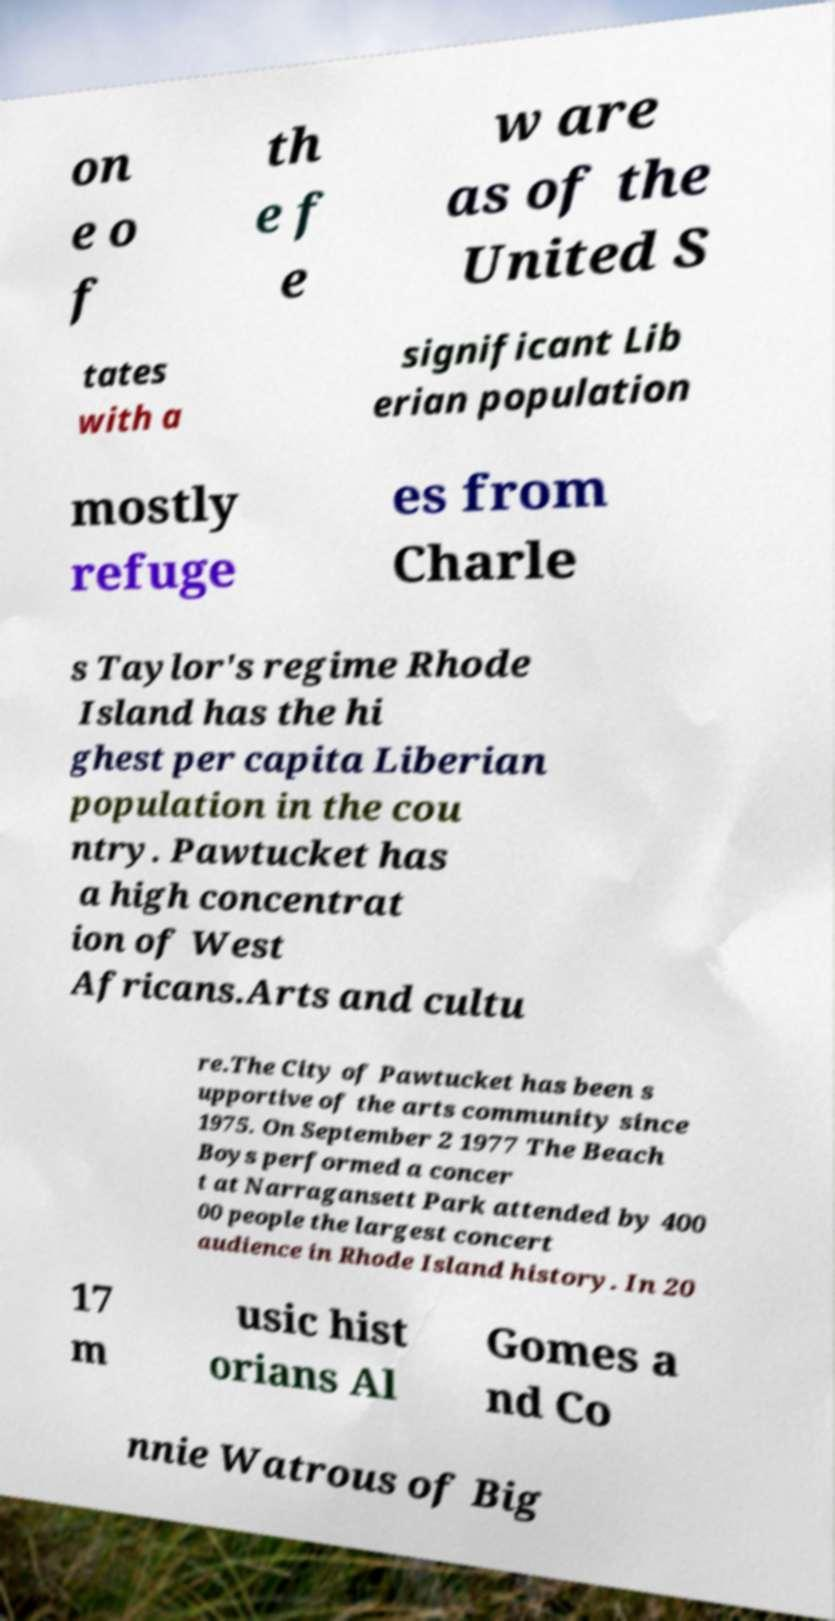Can you read and provide the text displayed in the image?This photo seems to have some interesting text. Can you extract and type it out for me? on e o f th e f e w are as of the United S tates with a significant Lib erian population mostly refuge es from Charle s Taylor's regime Rhode Island has the hi ghest per capita Liberian population in the cou ntry. Pawtucket has a high concentrat ion of West Africans.Arts and cultu re.The City of Pawtucket has been s upportive of the arts community since 1975. On September 2 1977 The Beach Boys performed a concer t at Narragansett Park attended by 400 00 people the largest concert audience in Rhode Island history. In 20 17 m usic hist orians Al Gomes a nd Co nnie Watrous of Big 